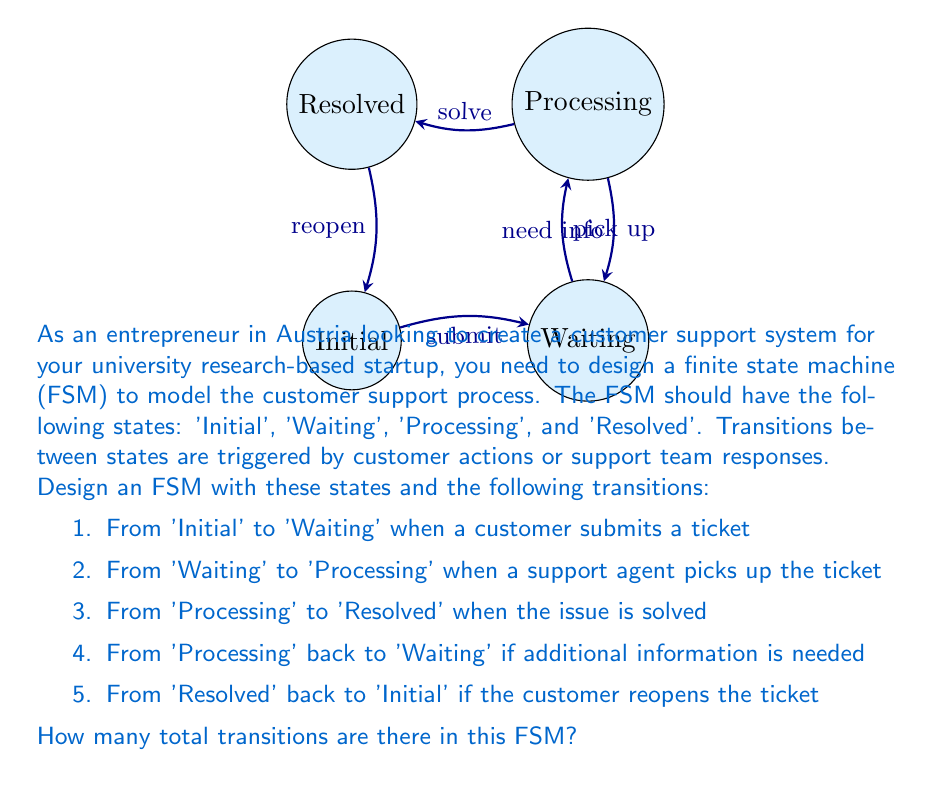Can you solve this math problem? To determine the total number of transitions in this Finite State Machine (FSM), we need to count all the distinct transitions between states as described in the question. Let's go through them step-by-step:

1. Initial → Waiting: This is the first transition when a customer submits a ticket.

2. Waiting → Processing: This occurs when a support agent picks up the ticket.

3. Processing → Resolved: This happens when the issue is solved.

4. Processing → Waiting: This transition is for cases where additional information is needed.

5. Resolved → Initial: This happens if the customer reopens the ticket.

Each of these transitions is unique and counts as one transition in our FSM.

To verify that we haven't missed any transitions, we can check that each state has at least one outgoing transition (except for possibly a final state, which we don't have in this case), and that all described behaviors are accounted for.

- Initial has 1 outgoing transition
- Waiting has 1 outgoing transition
- Processing has 2 outgoing transitions
- Resolved has 1 outgoing transition

All states have at least one outgoing transition, and all described behaviors are accounted for.

Therefore, the total number of transitions in this FSM is the sum of all these unique transitions:

$$ \text{Total Transitions} = 1 + 1 + 1 + 1 + 1 = 5 $$
Answer: 5 